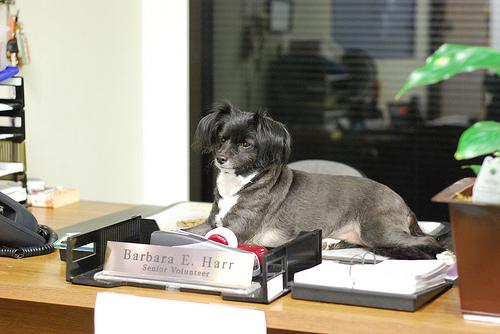Question: what is the animal shown here?
Choices:
A. A cat.
B. A dog.
C. A parrot.
D. A horse.
Answer with the letter. Answer: B Question: why is having the nameplate in the picture amusing?
Choices:
A. It looks as if the name refers to the dog.
B. It looks as if the name refers to the boy.
C. It looks as if the name refers to the girl.
D. It looks as if the name refers to no one.
Answer with the letter. Answer: A Question: where is the name plate?
Choices:
A. On the floor, in front of the desk.
B. Behind the desk, behind the dog.
C. At the front of the desk, in front of the dog.
D. On the back of the desk, in front of the dog.
Answer with the letter. Answer: C 